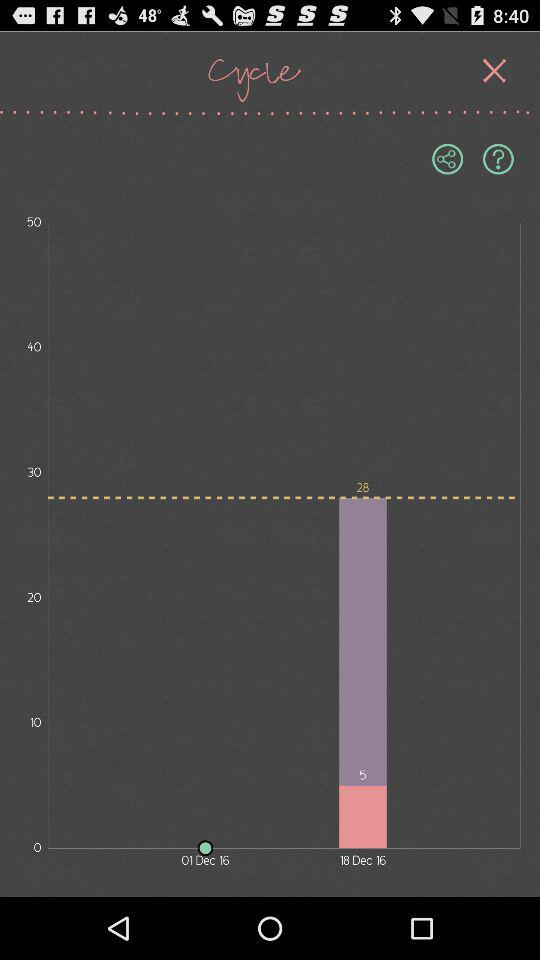On which step of progress are we on? You are on the first step of progress. 